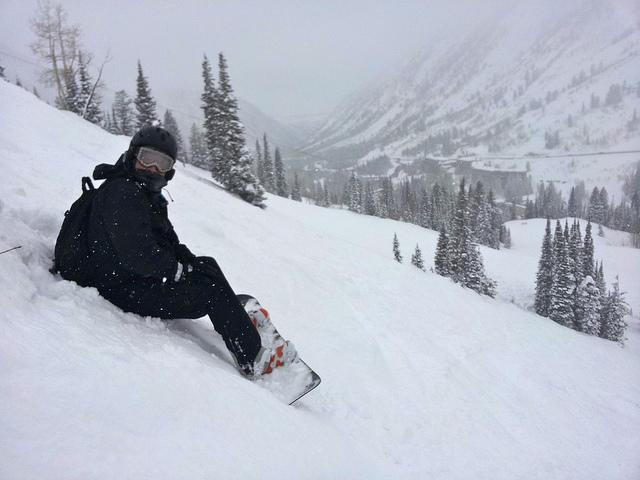How many people are there?
Give a very brief answer. 1. 